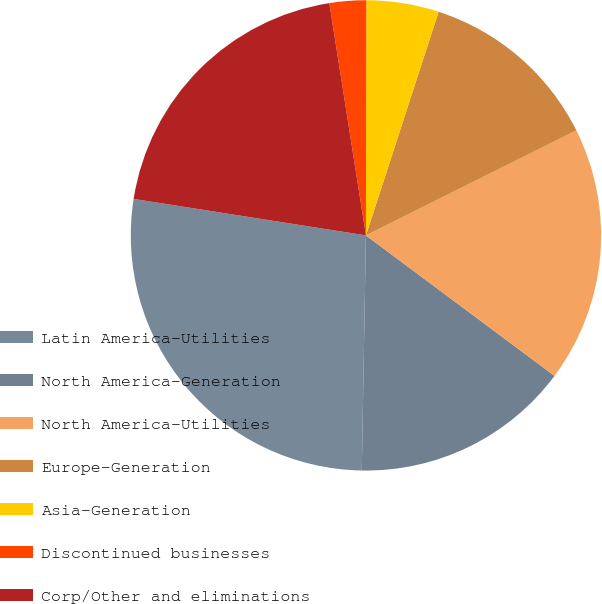<chart> <loc_0><loc_0><loc_500><loc_500><pie_chart><fcel>Latin America-Utilities<fcel>North America-Generation<fcel>North America-Utilities<fcel>Europe-Generation<fcel>Asia-Generation<fcel>Discontinued businesses<fcel>Corp/Other and eliminations<nl><fcel>27.2%<fcel>15.09%<fcel>17.56%<fcel>12.63%<fcel>4.98%<fcel>2.51%<fcel>20.03%<nl></chart> 